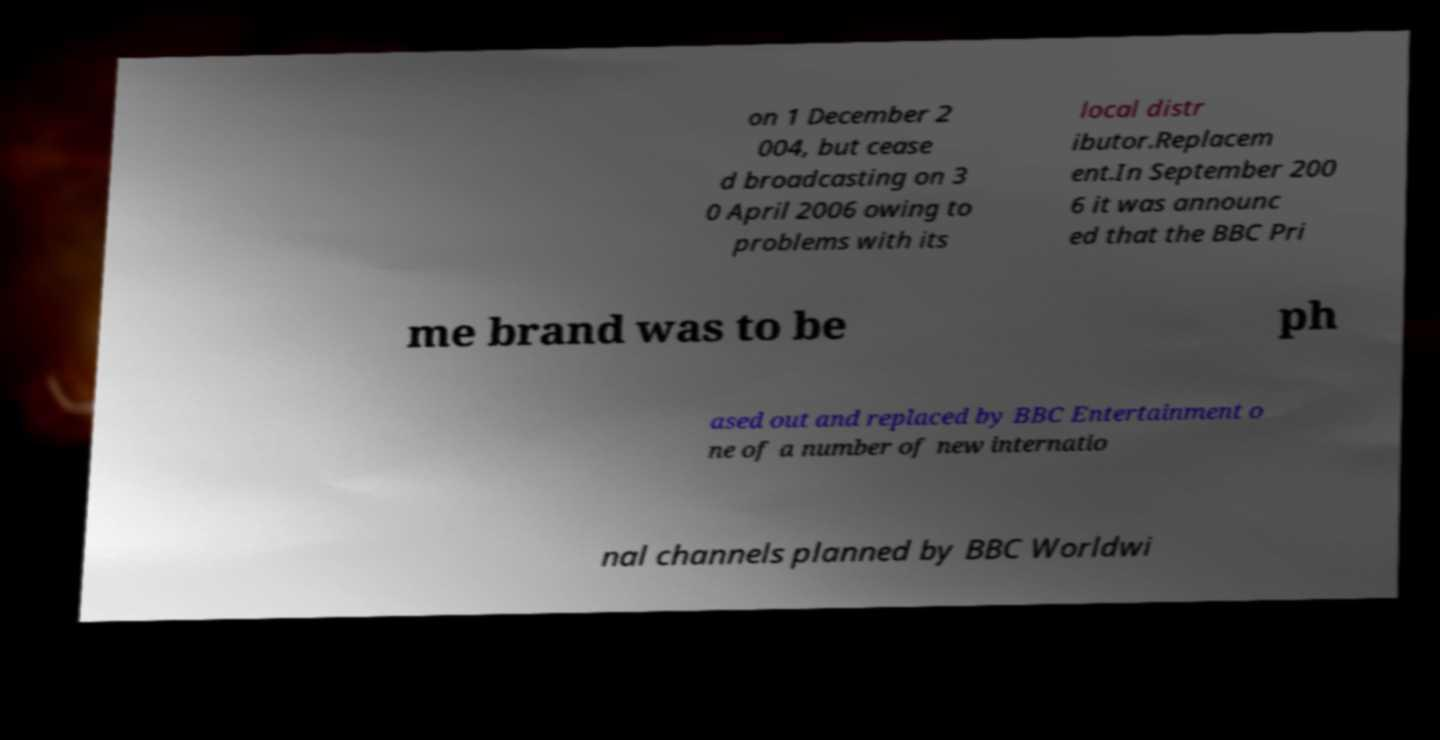What messages or text are displayed in this image? I need them in a readable, typed format. on 1 December 2 004, but cease d broadcasting on 3 0 April 2006 owing to problems with its local distr ibutor.Replacem ent.In September 200 6 it was announc ed that the BBC Pri me brand was to be ph ased out and replaced by BBC Entertainment o ne of a number of new internatio nal channels planned by BBC Worldwi 